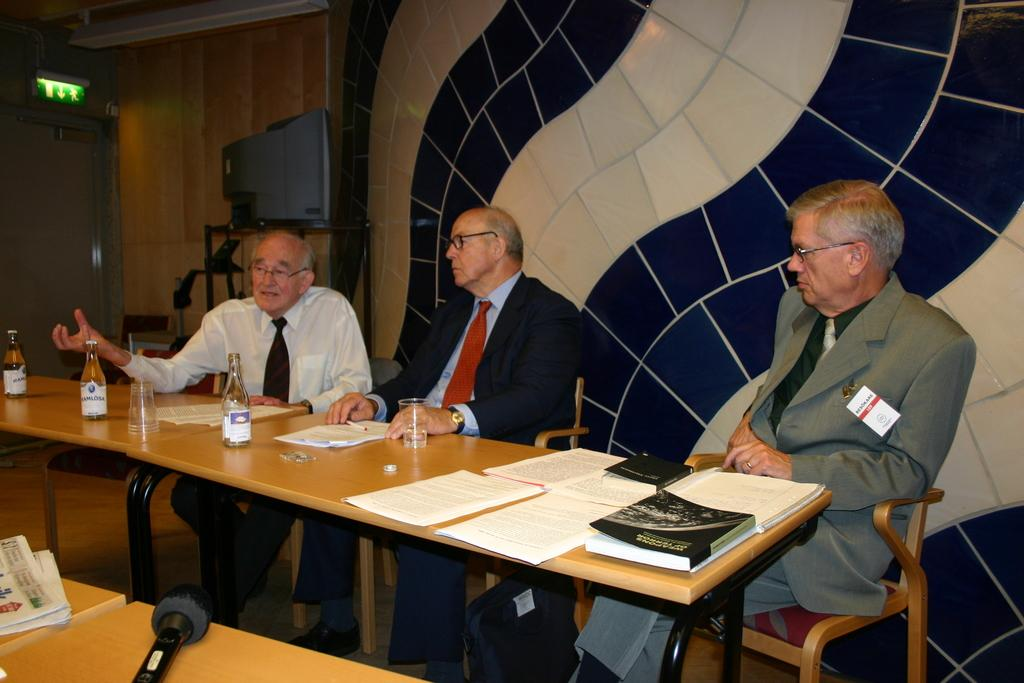How many people are present in the image? There are three people in the image. What are the people doing in the image? The people are sitting in chairs. What object can be seen in the image besides the people? There is a table in the image. What might the papers be used for in the image? The papers are visible in the image, but their purpose is not specified. What type of foot is visible on the table in the image? There is no foot visible on the table in the image. 